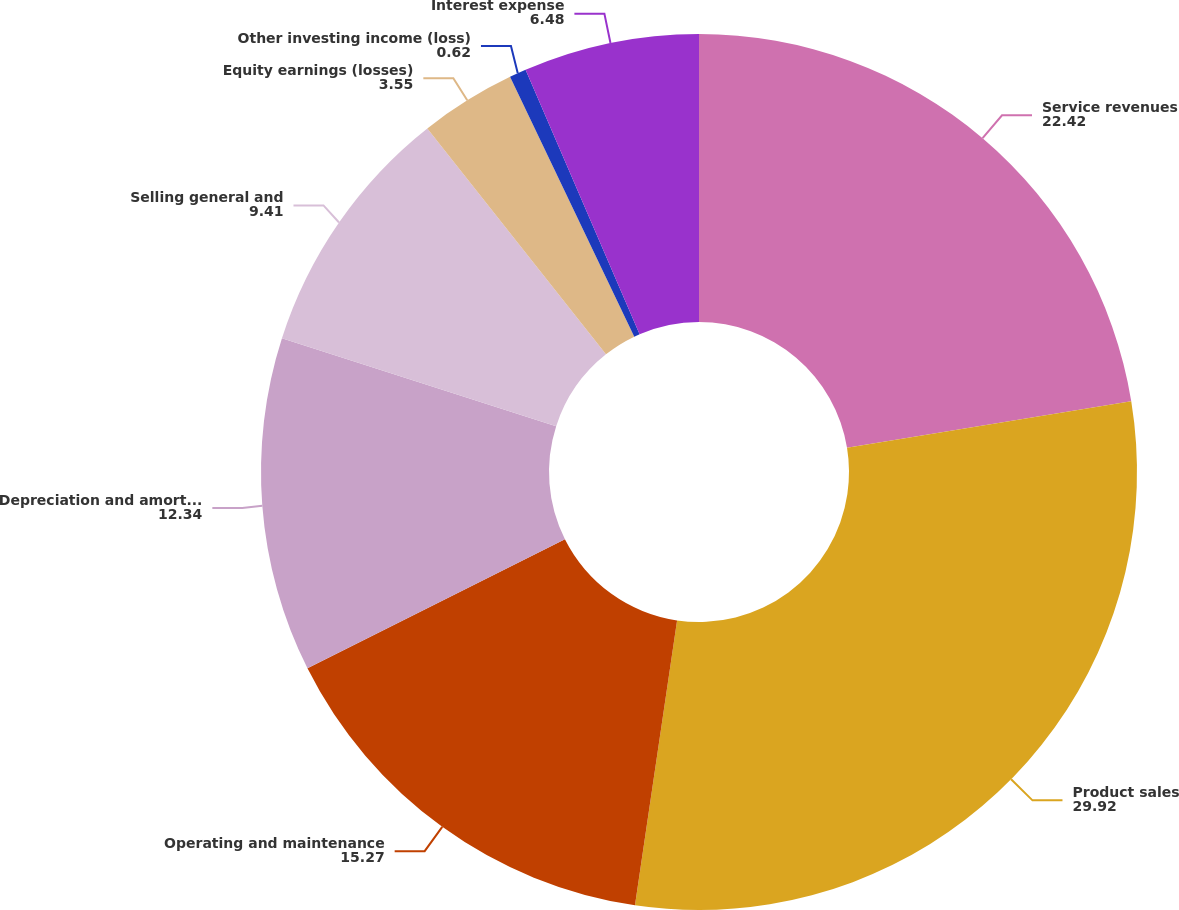Convert chart. <chart><loc_0><loc_0><loc_500><loc_500><pie_chart><fcel>Service revenues<fcel>Product sales<fcel>Operating and maintenance<fcel>Depreciation and amortization<fcel>Selling general and<fcel>Equity earnings (losses)<fcel>Other investing income (loss)<fcel>Interest expense<nl><fcel>22.42%<fcel>29.92%<fcel>15.27%<fcel>12.34%<fcel>9.41%<fcel>3.55%<fcel>0.62%<fcel>6.48%<nl></chart> 